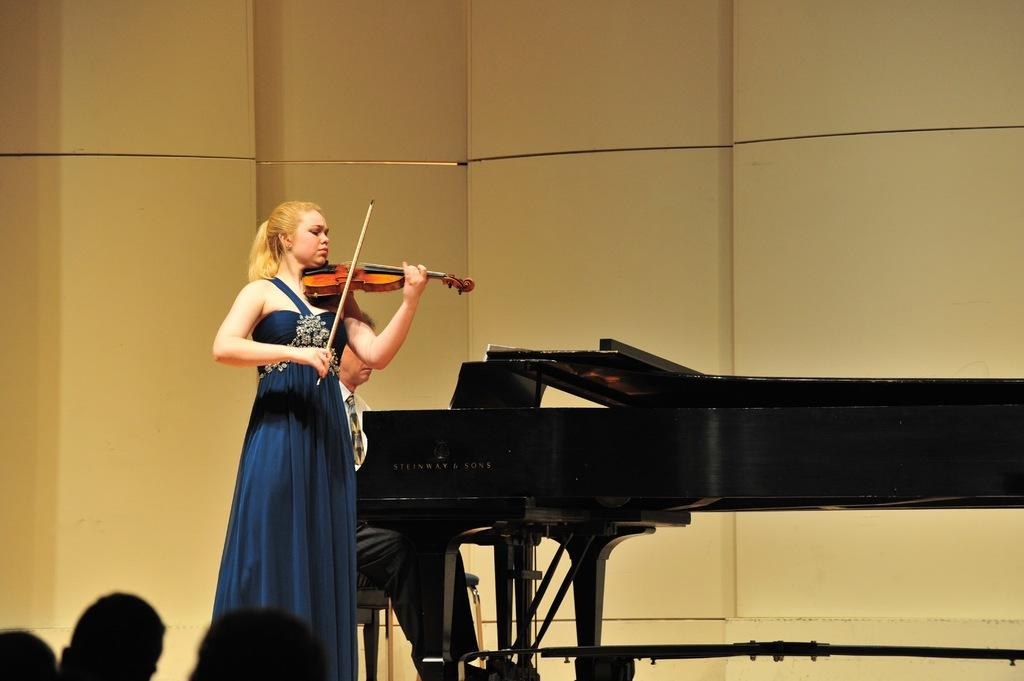Who is the main subject in the image? There is a woman in the image. What is the woman wearing? The woman is wearing a blue dress. What is the woman holding in the image? The woman is holding a stick and a violin. Can you describe the person sitting on a chair in the image? There is a person sitting on a chair in the image, and they are in front of a piano keyboard. What type of faucet can be seen in the image? There is no faucet present in the image. Is the woman wearing a locket in the image? The provided facts do not mention a locket, so it cannot be determined if the woman is wearing one. 